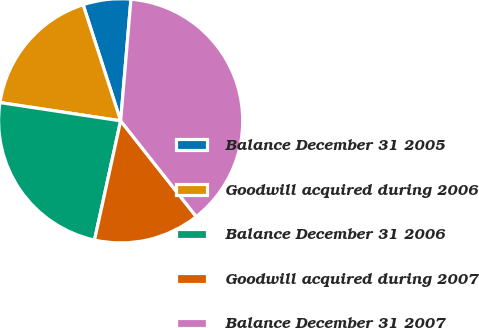<chart> <loc_0><loc_0><loc_500><loc_500><pie_chart><fcel>Balance December 31 2005<fcel>Goodwill acquired during 2006<fcel>Balance December 31 2006<fcel>Goodwill acquired during 2007<fcel>Balance December 31 2007<nl><fcel>6.32%<fcel>17.63%<fcel>23.95%<fcel>14.07%<fcel>38.02%<nl></chart> 